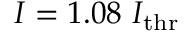Convert formula to latex. <formula><loc_0><loc_0><loc_500><loc_500>I = 1 . 0 8 I _ { t h r }</formula> 